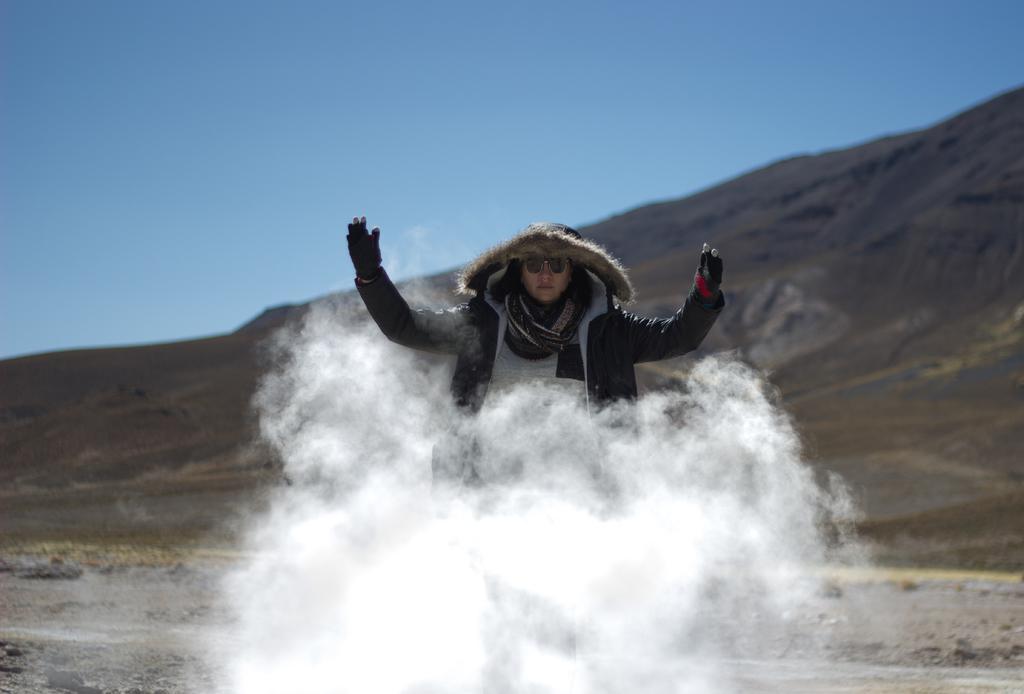Describe this image in one or two sentences. In this picture there is a woman in the center of the image and there is smoke in front of her. 